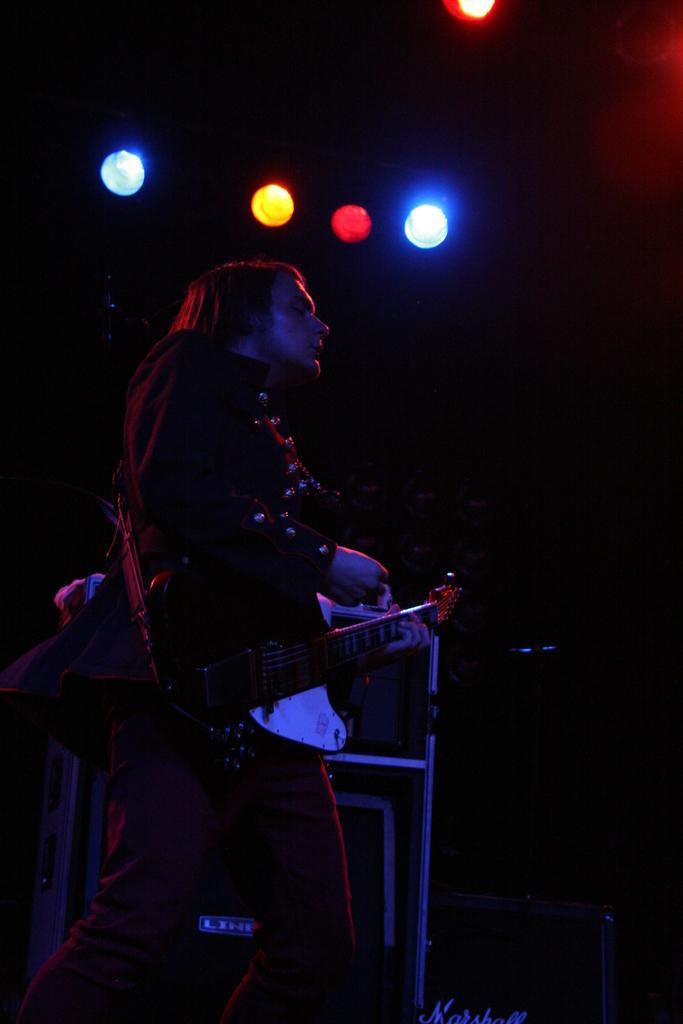In one or two sentences, can you explain what this image depicts? In this picture we can see a person, here we can see a musical instrument, lights and some objects and in the background we can see it is dark. 